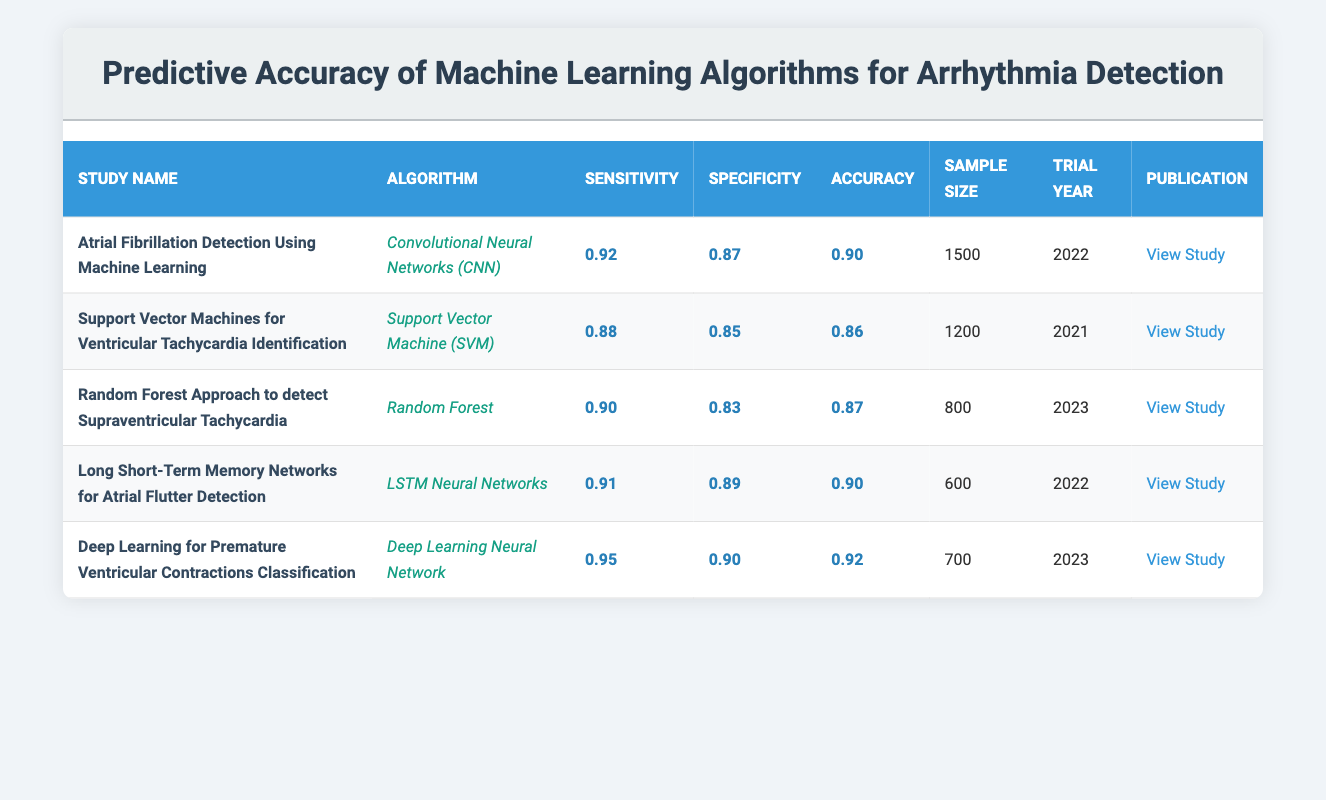What is the highest sensitivity reported among the trials? The sensitivity values are 0.92, 0.88, 0.90, 0.91, and 0.95 from the respective studies. The highest value is 0.95 from the "Deep Learning for Premature Ventricular Contractions Classification" study.
Answer: 0.95 Which algorithm had the lowest specificity? The specificities are 0.87, 0.85, 0.83, 0.89, and 0.90 from the respective studies. The lowest specificity is 0.83, which corresponds to the "Random Forest Approach to detect Supraventricular Tachycardia" study.
Answer: 0.83 What is the average accuracy of all the studies listed? The accuracies are 0.90, 0.86, 0.87, 0.90, and 0.92. To find the average, sum these values (0.90 + 0.86 + 0.87 + 0.90 + 0.92 = 4.45) and divide by the number of studies (5), which equals 4.45/5 = 0.89.
Answer: 0.89 Is the sample size for the study on "Support Vector Machines for Ventricular Tachycardia Identification" larger than 1000? The sample size listed for this study is 1200, which is greater than 1000.
Answer: Yes Which study had the highest sample size, and what is its accuracy? The sample sizes are 1500, 1200, 800, 600, and 700. The highest sample size is 1500 from the "Atrial Fibrillation Detection Using Machine Learning" study, which has an accuracy of 0.90.
Answer: Atrial Fibrillation Detection Using Machine Learning, 0.90 What percentage of studies achieved an accuracy of 0.90 or higher? Three studies have accuracies of 0.90 or higher (Atrial Fibrillation Detection, LSTM Neural Networks for Atrial Flutter, and Deep Learning for Premature Ventricular Contractions). There are five studies in total. The percentage is (3/5) * 100 = 60%.
Answer: 60% What is the difference in sensitivity between the "Deep Learning for Premature Ventricular Contractions Classification" and the "Support Vector Machines for Ventricular Tachycardia Identification"? The sensitivity values for these two studies are 0.95 and 0.88, respectively. The difference is 0.95 - 0.88 = 0.07.
Answer: 0.07 Did any of the studies published in 2023 have an accuracy lower than 0.90? The study "Random Forest Approach to detect Supraventricular Tachycardia" published in 2023 has an accuracy of 0.87, which is lower than 0.90.
Answer: Yes Which algorithm is associated with the highest accuracy and what is that accuracy? The algorithm with the highest accuracy is "Deep Learning Neural Network" from the study on Premature Ventricular Contractions Classification, which has an accuracy of 0.92.
Answer: Deep Learning Neural Network, 0.92 